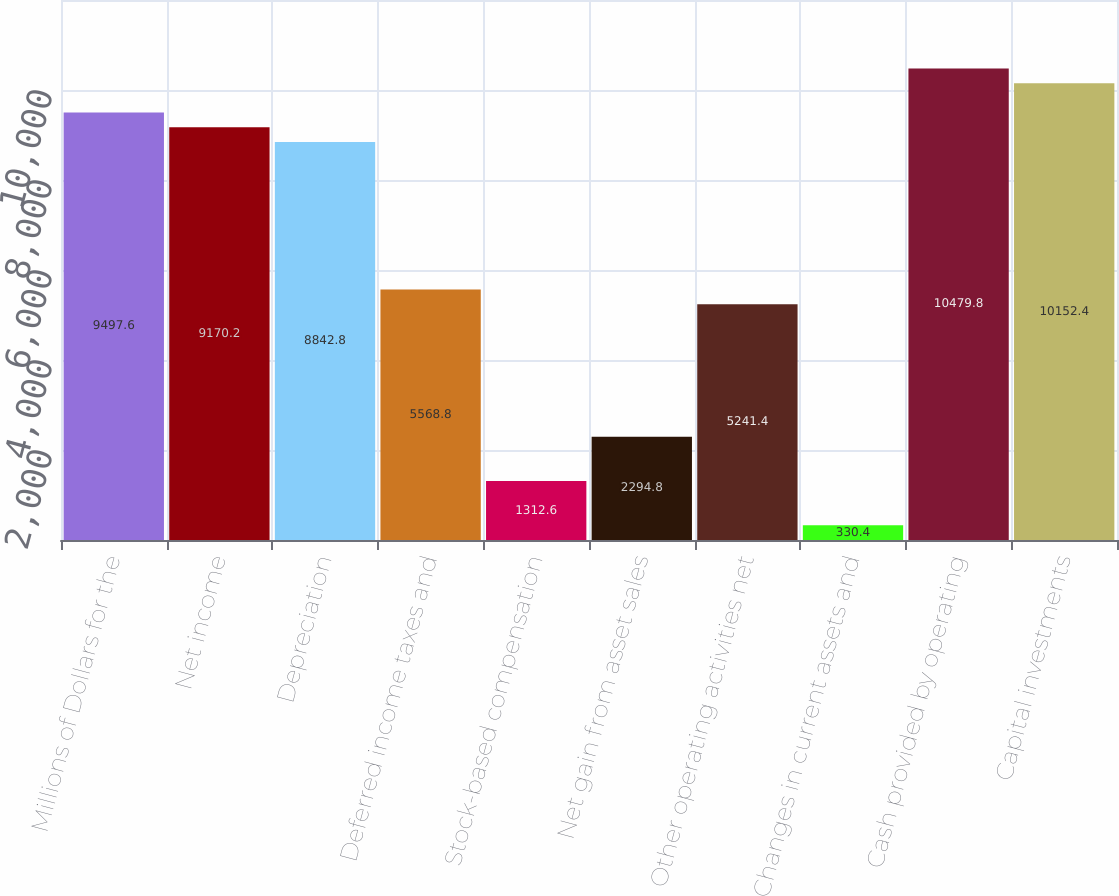Convert chart. <chart><loc_0><loc_0><loc_500><loc_500><bar_chart><fcel>Millions of Dollars for the<fcel>Net income<fcel>Depreciation<fcel>Deferred income taxes and<fcel>Stock-based compensation<fcel>Net gain from asset sales<fcel>Other operating activities net<fcel>Changes in current assets and<fcel>Cash provided by operating<fcel>Capital investments<nl><fcel>9497.6<fcel>9170.2<fcel>8842.8<fcel>5568.8<fcel>1312.6<fcel>2294.8<fcel>5241.4<fcel>330.4<fcel>10479.8<fcel>10152.4<nl></chart> 